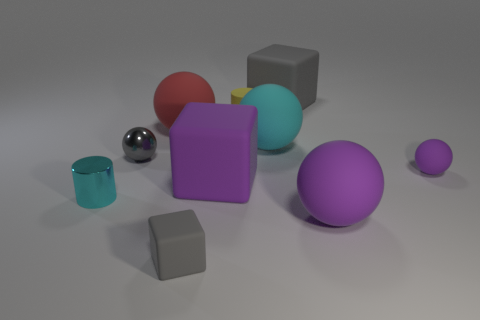Subtract all purple rubber balls. How many balls are left? 3 Subtract all cyan cubes. How many purple spheres are left? 2 Subtract 2 spheres. How many spheres are left? 3 Subtract all cyan balls. How many balls are left? 4 Subtract all cylinders. How many objects are left? 8 Add 7 tiny gray matte cubes. How many tiny gray matte cubes exist? 8 Subtract 1 gray balls. How many objects are left? 9 Subtract all green blocks. Subtract all brown cylinders. How many blocks are left? 3 Subtract all big gray shiny things. Subtract all tiny rubber things. How many objects are left? 7 Add 1 big purple cubes. How many big purple cubes are left? 2 